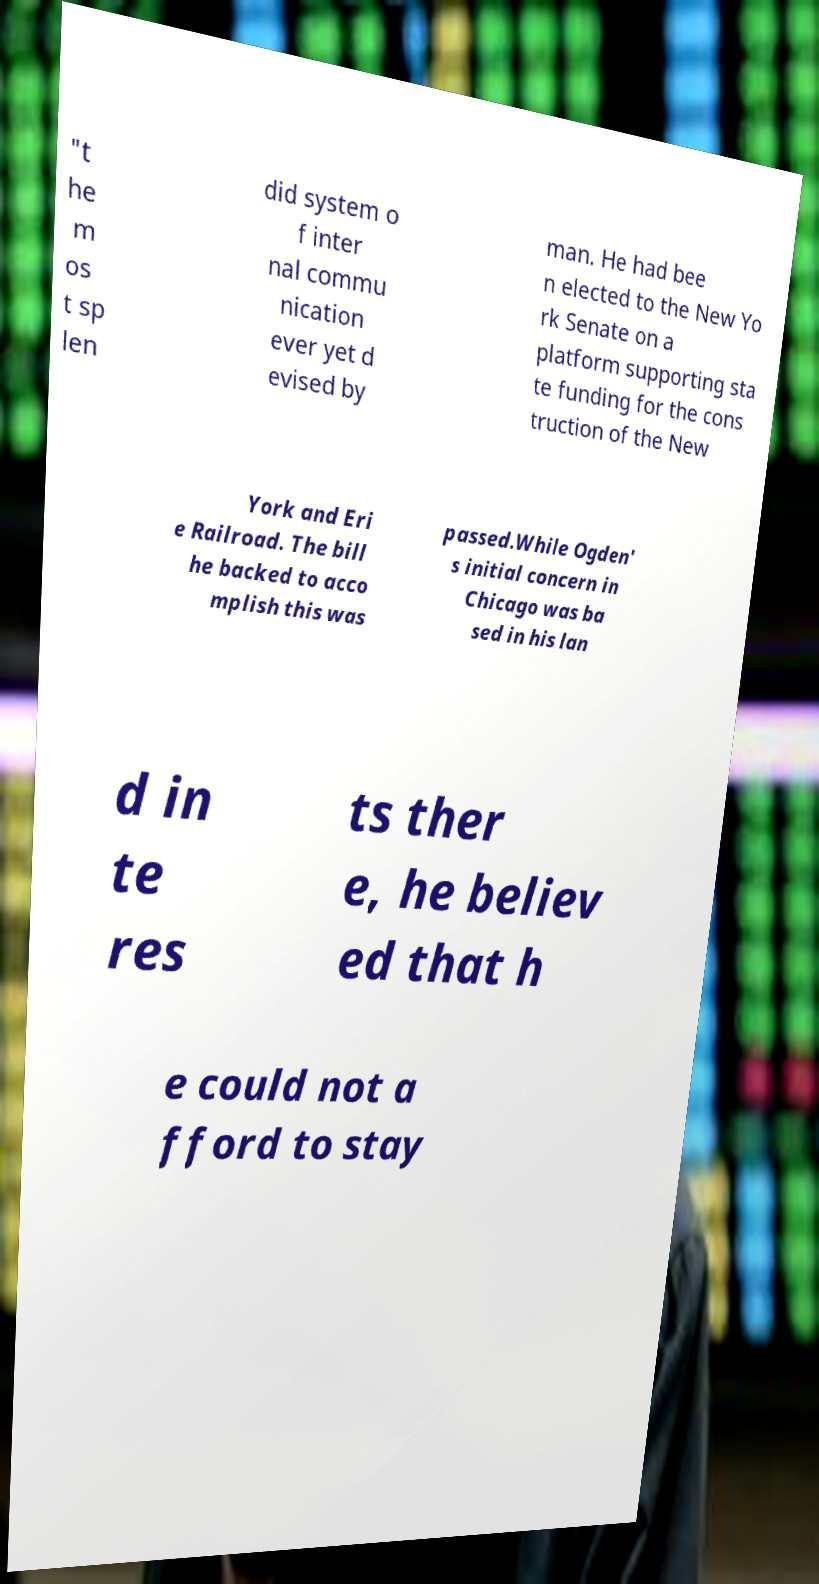Can you read and provide the text displayed in the image?This photo seems to have some interesting text. Can you extract and type it out for me? "t he m os t sp len did system o f inter nal commu nication ever yet d evised by man. He had bee n elected to the New Yo rk Senate on a platform supporting sta te funding for the cons truction of the New York and Eri e Railroad. The bill he backed to acco mplish this was passed.While Ogden' s initial concern in Chicago was ba sed in his lan d in te res ts ther e, he believ ed that h e could not a fford to stay 